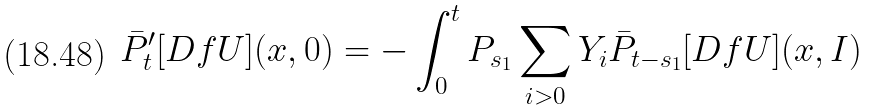<formula> <loc_0><loc_0><loc_500><loc_500>\bar { P } ^ { \prime } _ { t } [ D f U ] ( x , 0 ) = - \int _ { 0 } ^ { t } P _ { s _ { 1 } } \sum _ { i > 0 } Y _ { i } \bar { P } _ { t - s _ { 1 } } [ D f U ] ( x , I )</formula> 